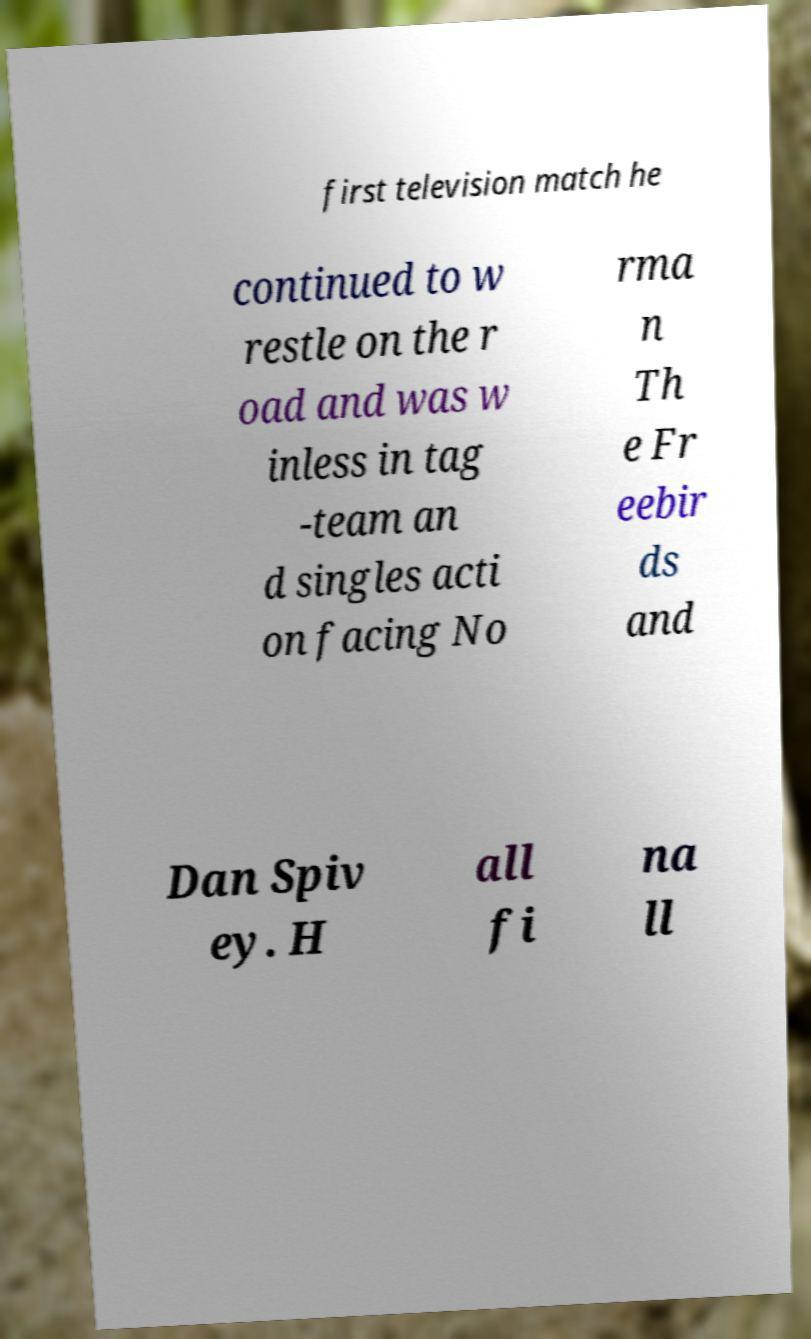Could you extract and type out the text from this image? first television match he continued to w restle on the r oad and was w inless in tag -team an d singles acti on facing No rma n Th e Fr eebir ds and Dan Spiv ey. H all fi na ll 